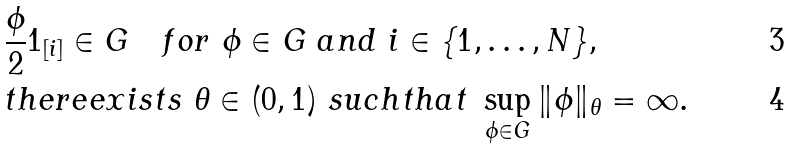Convert formula to latex. <formula><loc_0><loc_0><loc_500><loc_500>& \frac { \phi } { 2 } 1 _ { [ i ] } \in G \quad f o r \ \phi \in G \ a n d \ i \in \{ 1 , \dots , N \} , \\ & t h e r e e x i s t s \ \theta \in ( 0 , 1 ) \ s u c h t h a t \ \sup _ { \phi \in G } \| \phi \| _ { \theta } = \infty .</formula> 